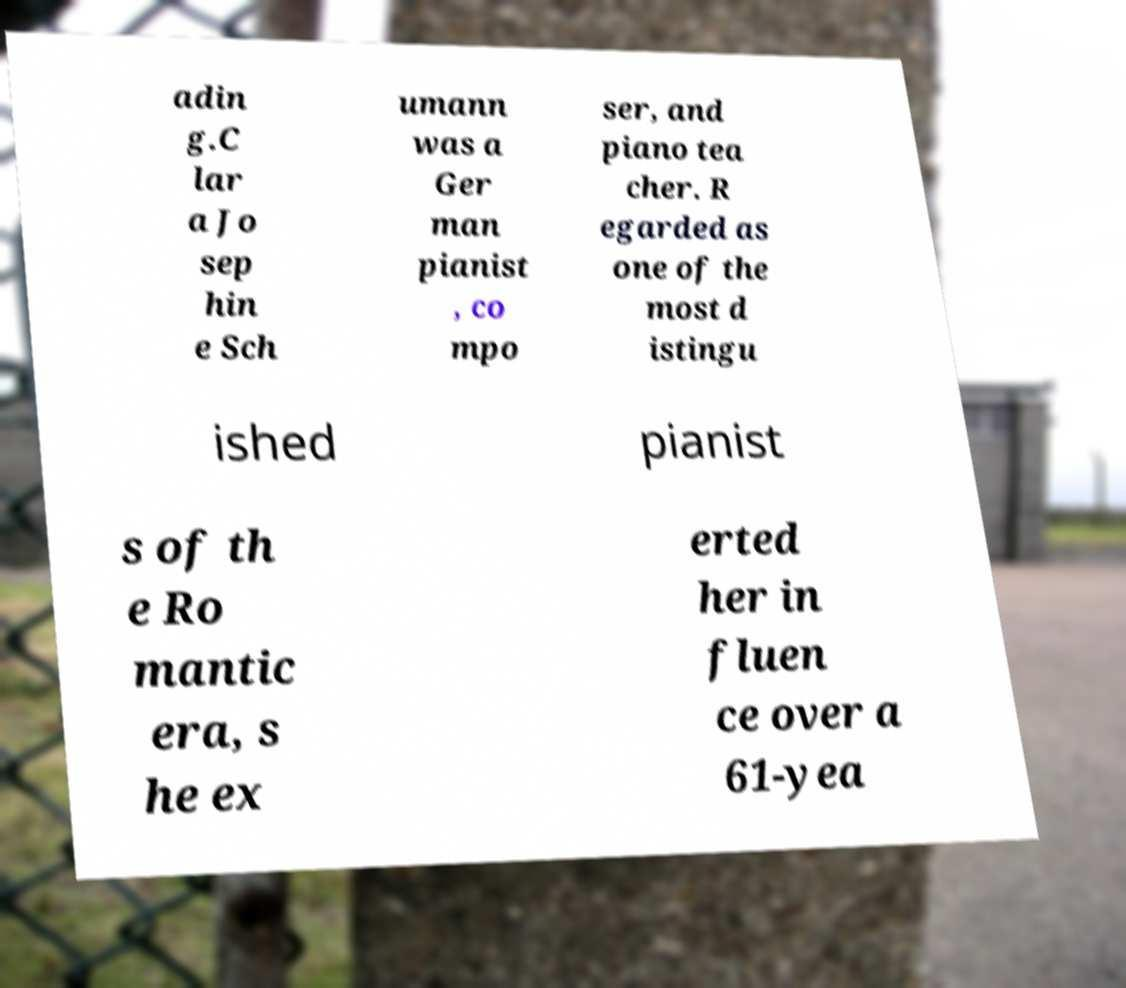Can you accurately transcribe the text from the provided image for me? adin g.C lar a Jo sep hin e Sch umann was a Ger man pianist , co mpo ser, and piano tea cher. R egarded as one of the most d istingu ished pianist s of th e Ro mantic era, s he ex erted her in fluen ce over a 61-yea 